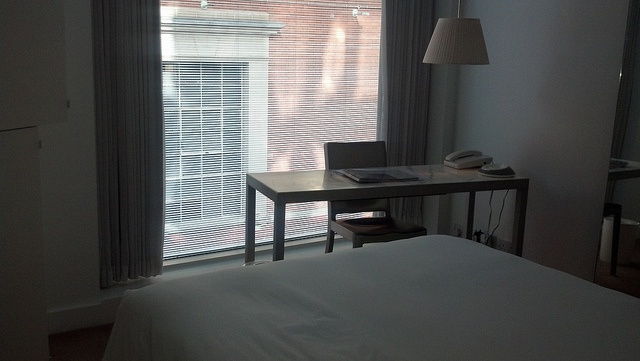Describe the objects in this image and their specific colors. I can see bed in black and purple tones, dining table in black, gray, and darkgray tones, chair in black, gray, lightgray, and darkgray tones, and book in black and gray tones in this image. 